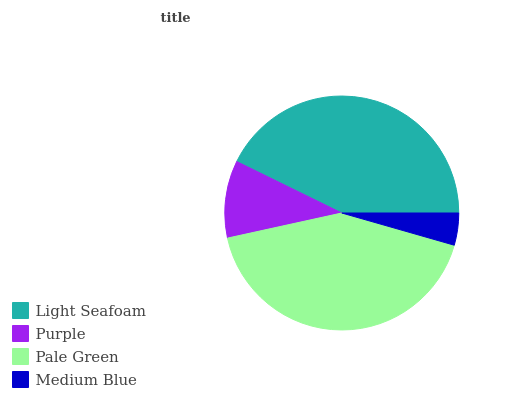Is Medium Blue the minimum?
Answer yes or no. Yes. Is Light Seafoam the maximum?
Answer yes or no. Yes. Is Purple the minimum?
Answer yes or no. No. Is Purple the maximum?
Answer yes or no. No. Is Light Seafoam greater than Purple?
Answer yes or no. Yes. Is Purple less than Light Seafoam?
Answer yes or no. Yes. Is Purple greater than Light Seafoam?
Answer yes or no. No. Is Light Seafoam less than Purple?
Answer yes or no. No. Is Pale Green the high median?
Answer yes or no. Yes. Is Purple the low median?
Answer yes or no. Yes. Is Purple the high median?
Answer yes or no. No. Is Light Seafoam the low median?
Answer yes or no. No. 